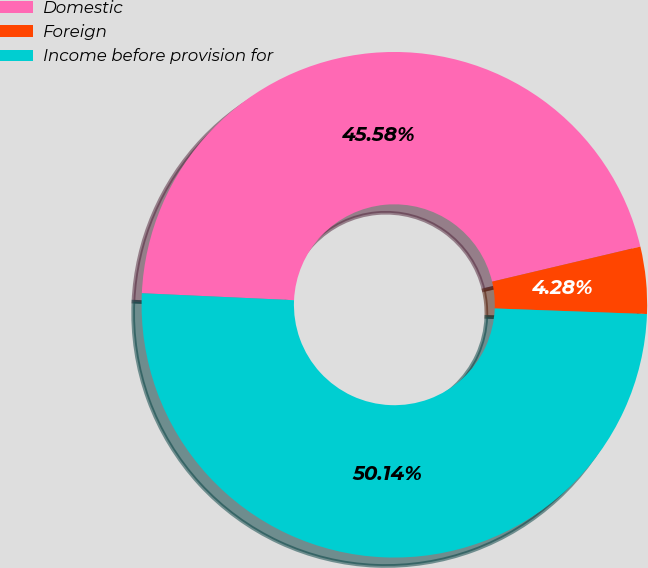Convert chart. <chart><loc_0><loc_0><loc_500><loc_500><pie_chart><fcel>Domestic<fcel>Foreign<fcel>Income before provision for<nl><fcel>45.58%<fcel>4.28%<fcel>50.14%<nl></chart> 